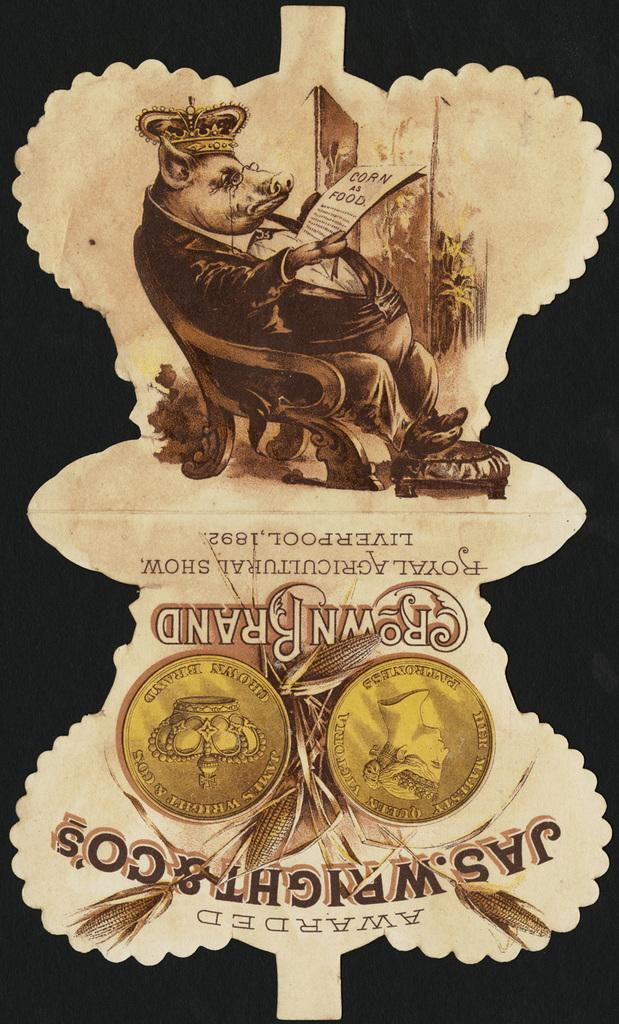<image>
Provide a brief description of the given image. A notice of an award won by Crown Brand in Liverpool in 1892. 